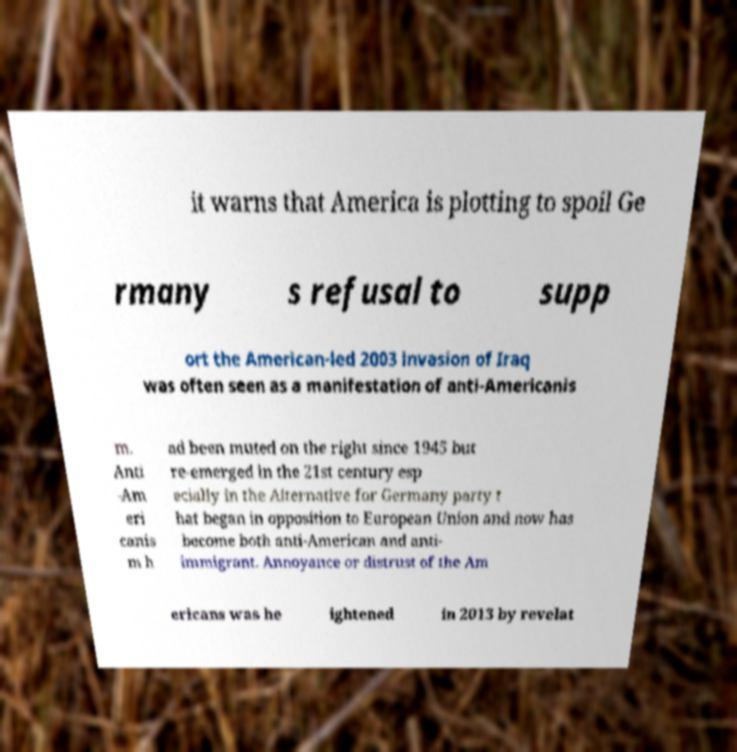Could you extract and type out the text from this image? it warns that America is plotting to spoil Ge rmany s refusal to supp ort the American-led 2003 invasion of Iraq was often seen as a manifestation of anti-Americanis m. Anti -Am eri canis m h ad been muted on the right since 1945 but re-emerged in the 21st century esp ecially in the Alternative for Germany party t hat began in opposition to European Union and now has become both anti-American and anti- immigrant. Annoyance or distrust of the Am ericans was he ightened in 2013 by revelat 